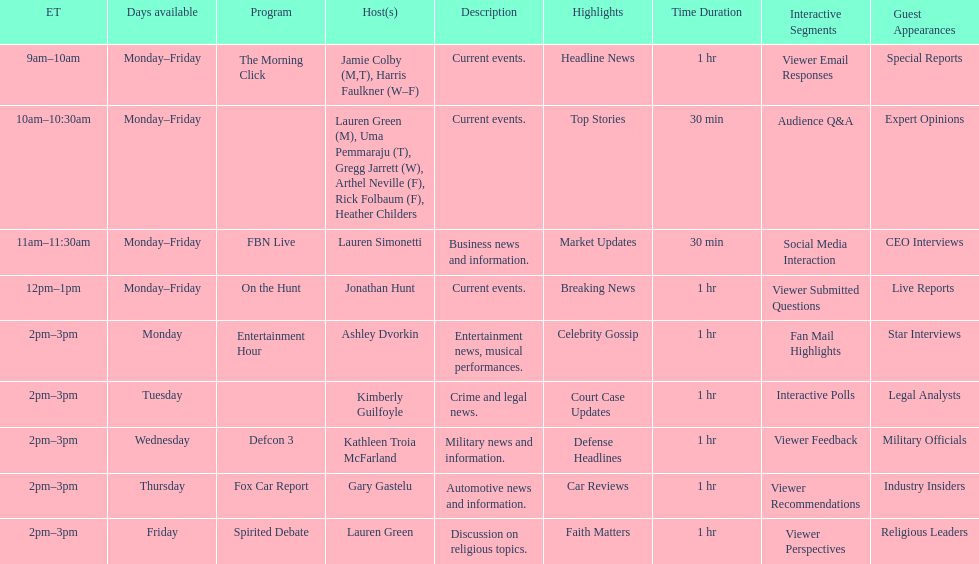What is the first show to play on monday mornings? The Morning Click. 